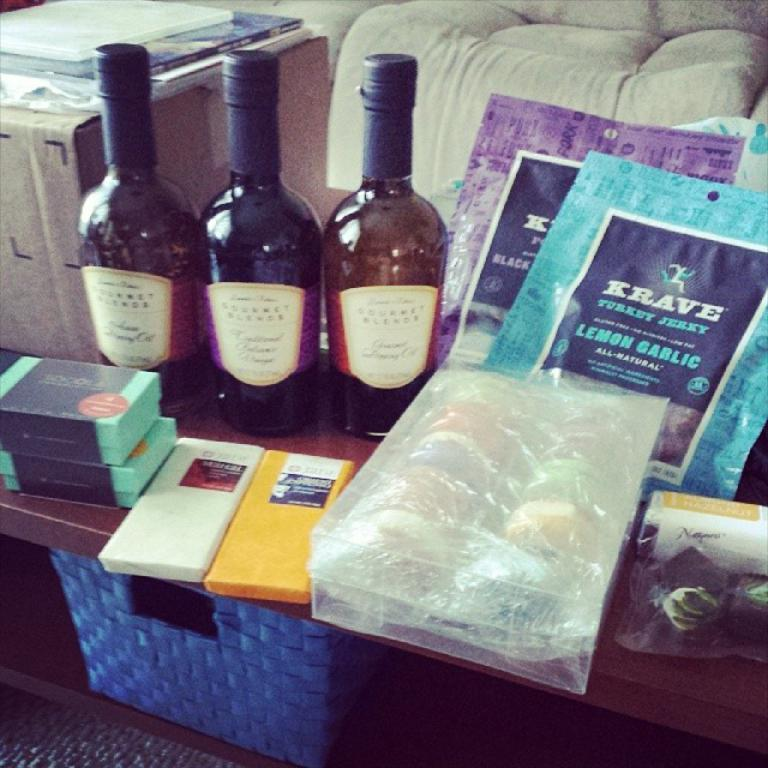What type of beverages are on the table in the image? There are wine bottles on the table. What else can be seen on the table besides the wine bottles? There are food items wrapped in covers on the table. What type of knowledge is being shared at the club in the image? There is no club or knowledge sharing activity present in the image; it only features wine bottles and food items wrapped in covers on a table. 